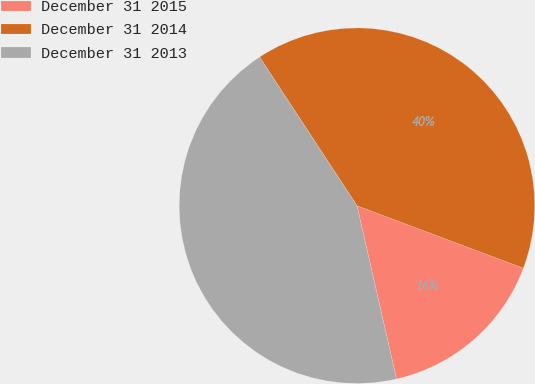<chart> <loc_0><loc_0><loc_500><loc_500><pie_chart><fcel>December 31 2015<fcel>December 31 2014<fcel>December 31 2013<nl><fcel>15.71%<fcel>39.95%<fcel>44.34%<nl></chart> 